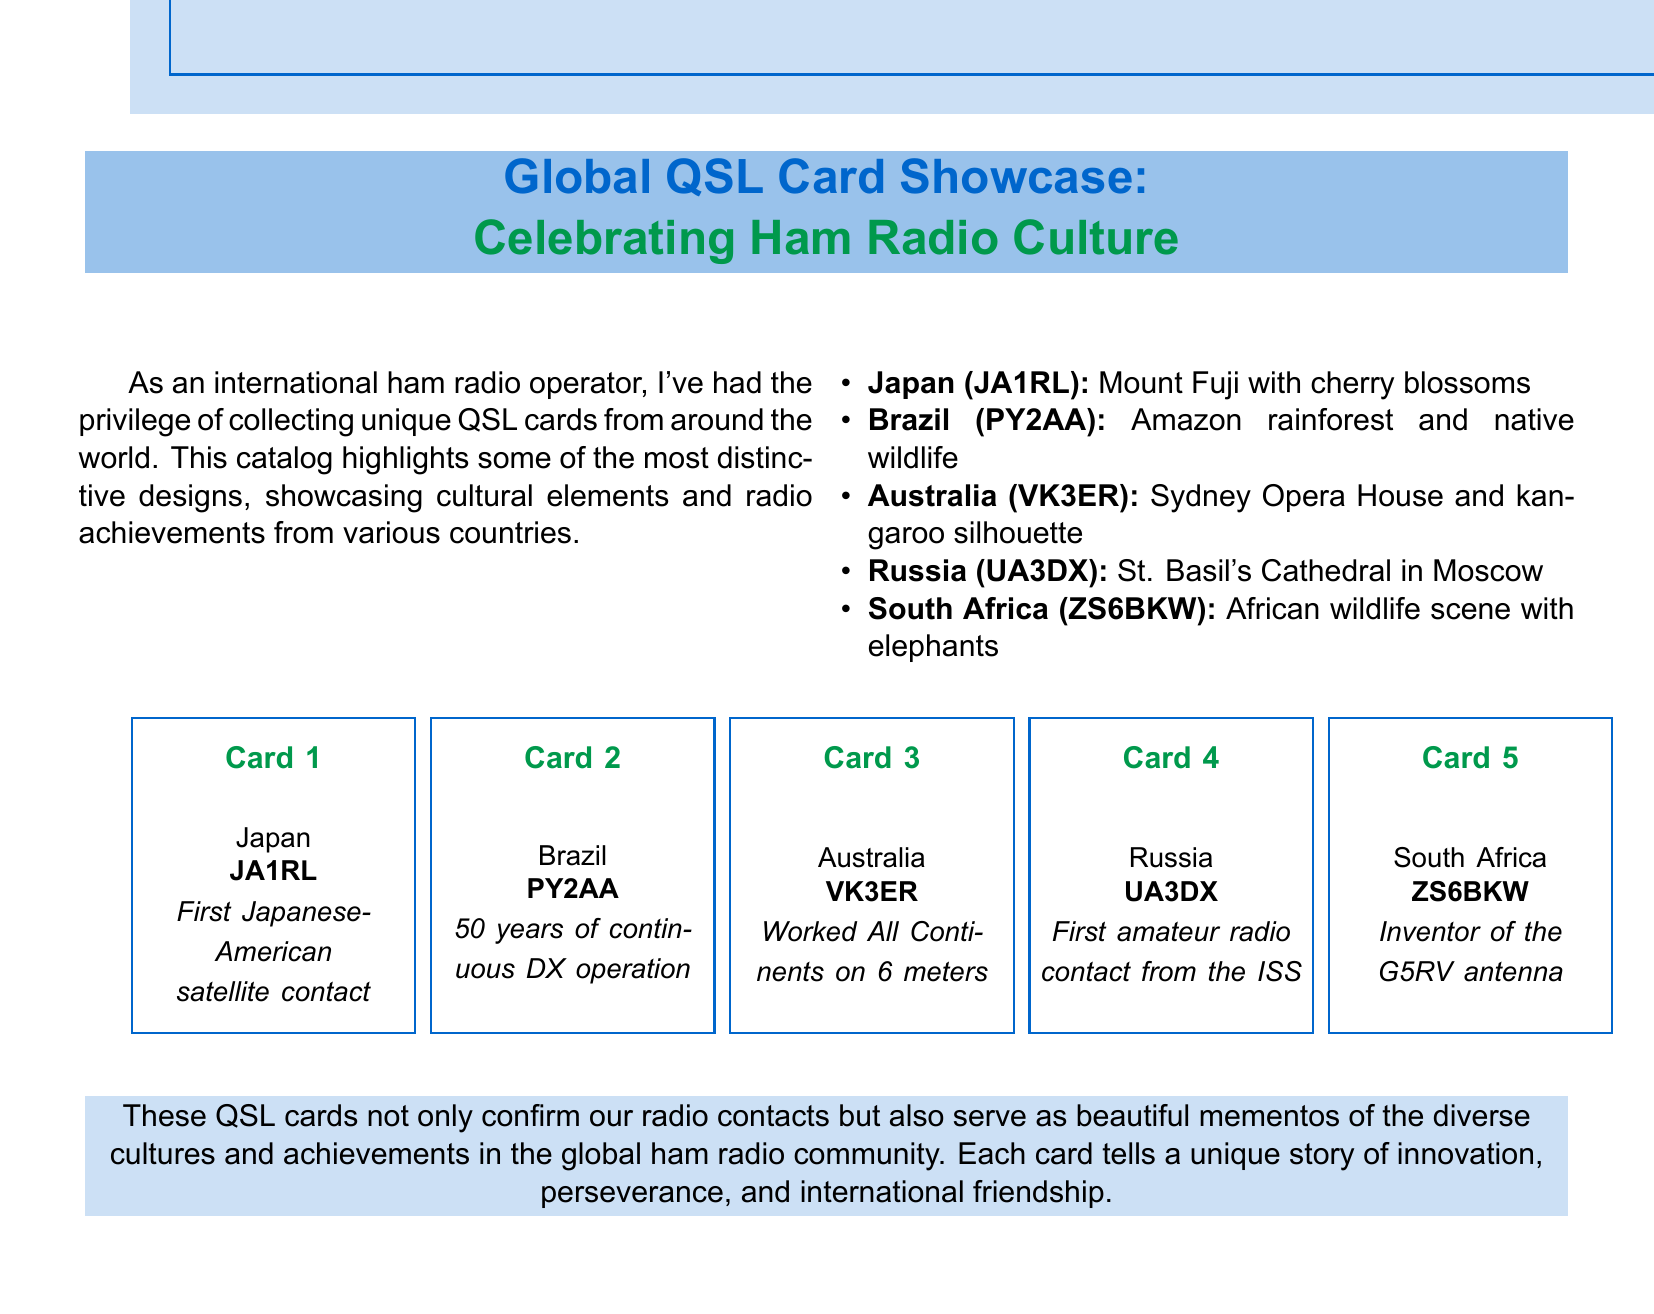What is the title of the catalog? The title of the catalog is presented prominently at the top of the document.
Answer: Global QSL Card Showcase: Celebrating Ham Radio Culture How many QSL card designs are showcased? The document lists a total of five specific QSL card designs from different countries.
Answer: 5 What is depicted on the Japanese QSL card? The description of the Japanese QSL card includes cultural elements that are visually significant.
Answer: Mount Fuji with cherry blossoms What achievement is highlighted for Brazil (PY2AA)? The document notes a specific milestone related to Brazil's ham radio operations that showcases its significance.
Answer: 50 years of continuous DX operation Who is the owner of the South African QSL card? The document lists the call sign for the South African operator associated with a specific achievement.
Answer: ZS6BKW What type of scene is featured on the South African QSL card? The document describes the visual elements present in the South African QSL card, reflecting its cultural context.
Answer: African wildlife scene with elephants What is one common purpose of the QSL cards mentioned? The document states a specific function of the QSL cards within the ham radio community.
Answer: Confirm radio contacts Which country features the Sydney Opera House on its QSL card? The document mentions this particular Australian landmark prominently in connection with its radio operator.
Answer: Australia What unique event is associated with the Russian QSL card? The document highlights a significant milestone pertaining to a specific achievement within the Russian ham radio context.
Answer: First amateur radio contact from the ISS 